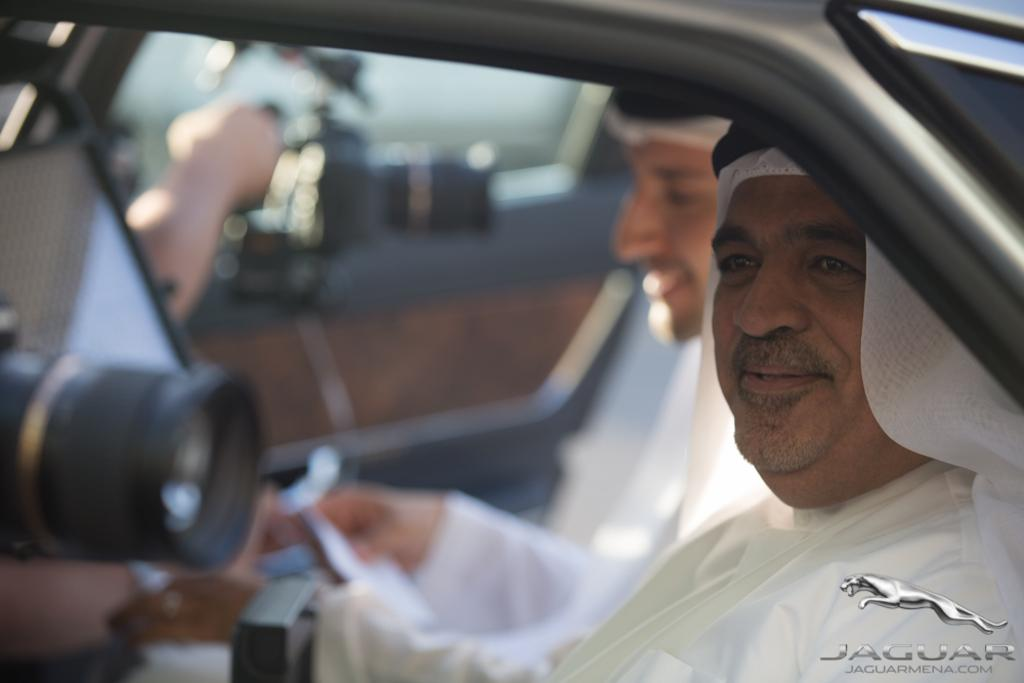How many people are in the image? There are two persons in the image. What object is present in the image that is commonly used for capturing images? There is a camera in the image. Can you describe the background of the image? There is a blurry reflection in the background of the image. What type of eggnog is being consumed by the persons in the image? There is no eggnog present in the image, and the persons are not consuming any beverages. What religious symbols can be seen in the image? There are no religious symbols present in the image. 